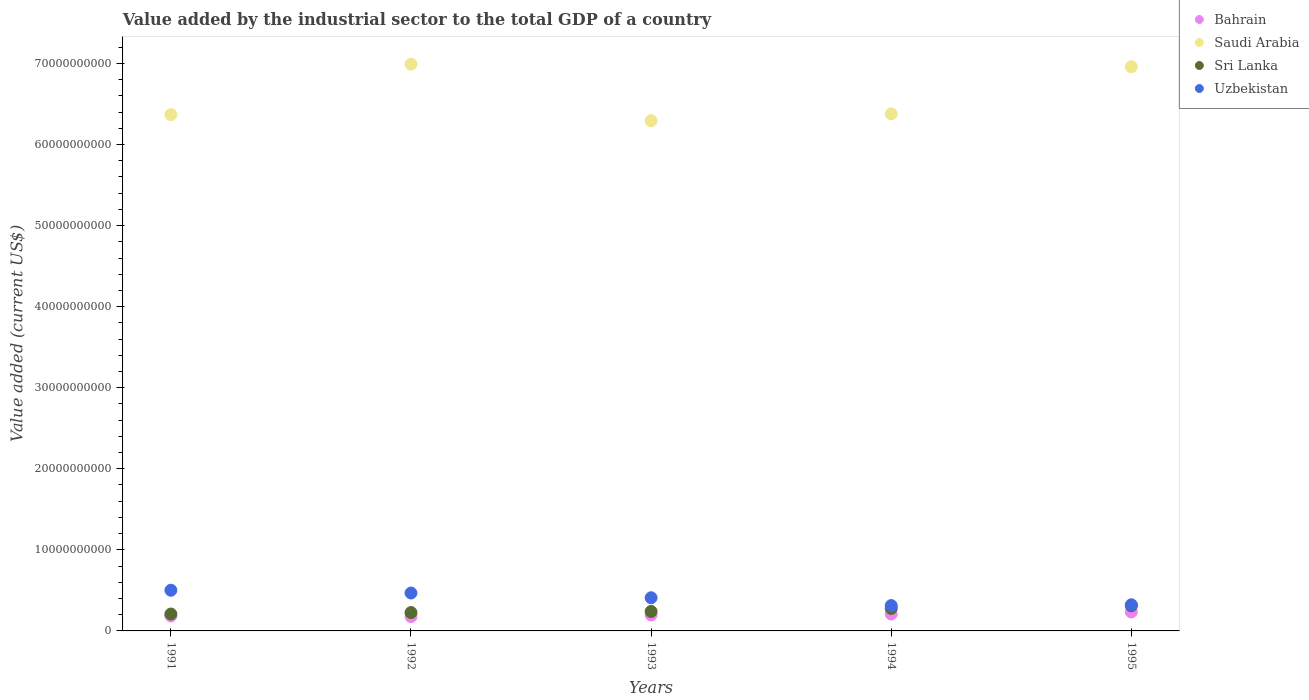What is the value added by the industrial sector to the total GDP in Saudi Arabia in 1993?
Make the answer very short. 6.29e+1. Across all years, what is the maximum value added by the industrial sector to the total GDP in Sri Lanka?
Your answer should be compact. 3.10e+09. Across all years, what is the minimum value added by the industrial sector to the total GDP in Bahrain?
Your answer should be compact. 1.77e+09. In which year was the value added by the industrial sector to the total GDP in Saudi Arabia minimum?
Offer a very short reply. 1993. What is the total value added by the industrial sector to the total GDP in Sri Lanka in the graph?
Provide a succinct answer. 1.26e+1. What is the difference between the value added by the industrial sector to the total GDP in Saudi Arabia in 1992 and that in 1994?
Make the answer very short. 6.12e+09. What is the difference between the value added by the industrial sector to the total GDP in Uzbekistan in 1993 and the value added by the industrial sector to the total GDP in Saudi Arabia in 1994?
Your response must be concise. -5.97e+1. What is the average value added by the industrial sector to the total GDP in Sri Lanka per year?
Provide a short and direct response. 2.52e+09. In the year 1991, what is the difference between the value added by the industrial sector to the total GDP in Saudi Arabia and value added by the industrial sector to the total GDP in Bahrain?
Your answer should be compact. 6.18e+1. In how many years, is the value added by the industrial sector to the total GDP in Sri Lanka greater than 24000000000 US$?
Ensure brevity in your answer.  0. What is the ratio of the value added by the industrial sector to the total GDP in Bahrain in 1991 to that in 1993?
Your answer should be very brief. 0.93. Is the value added by the industrial sector to the total GDP in Sri Lanka in 1992 less than that in 1995?
Your response must be concise. Yes. Is the difference between the value added by the industrial sector to the total GDP in Saudi Arabia in 1994 and 1995 greater than the difference between the value added by the industrial sector to the total GDP in Bahrain in 1994 and 1995?
Provide a succinct answer. No. What is the difference between the highest and the second highest value added by the industrial sector to the total GDP in Uzbekistan?
Your answer should be compact. 3.42e+08. What is the difference between the highest and the lowest value added by the industrial sector to the total GDP in Bahrain?
Make the answer very short. 5.69e+08. How many dotlines are there?
Give a very brief answer. 4. How many years are there in the graph?
Provide a short and direct response. 5. Does the graph contain any zero values?
Your response must be concise. No. How many legend labels are there?
Your answer should be very brief. 4. How are the legend labels stacked?
Keep it short and to the point. Vertical. What is the title of the graph?
Provide a succinct answer. Value added by the industrial sector to the total GDP of a country. Does "Slovenia" appear as one of the legend labels in the graph?
Give a very brief answer. No. What is the label or title of the X-axis?
Your answer should be very brief. Years. What is the label or title of the Y-axis?
Keep it short and to the point. Value added (current US$). What is the Value added (current US$) in Bahrain in 1991?
Your answer should be very brief. 1.84e+09. What is the Value added (current US$) in Saudi Arabia in 1991?
Give a very brief answer. 6.37e+1. What is the Value added (current US$) of Sri Lanka in 1991?
Offer a very short reply. 2.09e+09. What is the Value added (current US$) of Uzbekistan in 1991?
Offer a terse response. 5.02e+09. What is the Value added (current US$) of Bahrain in 1992?
Your response must be concise. 1.77e+09. What is the Value added (current US$) in Saudi Arabia in 1992?
Your response must be concise. 6.99e+1. What is the Value added (current US$) of Sri Lanka in 1992?
Your answer should be very brief. 2.26e+09. What is the Value added (current US$) of Uzbekistan in 1992?
Offer a terse response. 4.68e+09. What is the Value added (current US$) in Bahrain in 1993?
Keep it short and to the point. 1.97e+09. What is the Value added (current US$) of Saudi Arabia in 1993?
Offer a terse response. 6.29e+1. What is the Value added (current US$) of Sri Lanka in 1993?
Your response must be concise. 2.40e+09. What is the Value added (current US$) in Uzbekistan in 1993?
Offer a terse response. 4.09e+09. What is the Value added (current US$) in Bahrain in 1994?
Give a very brief answer. 2.08e+09. What is the Value added (current US$) in Saudi Arabia in 1994?
Keep it short and to the point. 6.38e+1. What is the Value added (current US$) of Sri Lanka in 1994?
Offer a terse response. 2.77e+09. What is the Value added (current US$) in Uzbekistan in 1994?
Your response must be concise. 3.13e+09. What is the Value added (current US$) of Bahrain in 1995?
Your answer should be compact. 2.34e+09. What is the Value added (current US$) of Saudi Arabia in 1995?
Your answer should be compact. 6.96e+1. What is the Value added (current US$) of Sri Lanka in 1995?
Your response must be concise. 3.10e+09. What is the Value added (current US$) of Uzbekistan in 1995?
Keep it short and to the point. 3.22e+09. Across all years, what is the maximum Value added (current US$) of Bahrain?
Your response must be concise. 2.34e+09. Across all years, what is the maximum Value added (current US$) in Saudi Arabia?
Offer a very short reply. 6.99e+1. Across all years, what is the maximum Value added (current US$) in Sri Lanka?
Provide a succinct answer. 3.10e+09. Across all years, what is the maximum Value added (current US$) of Uzbekistan?
Provide a short and direct response. 5.02e+09. Across all years, what is the minimum Value added (current US$) in Bahrain?
Provide a short and direct response. 1.77e+09. Across all years, what is the minimum Value added (current US$) of Saudi Arabia?
Keep it short and to the point. 6.29e+1. Across all years, what is the minimum Value added (current US$) of Sri Lanka?
Your answer should be compact. 2.09e+09. Across all years, what is the minimum Value added (current US$) in Uzbekistan?
Keep it short and to the point. 3.13e+09. What is the total Value added (current US$) in Bahrain in the graph?
Give a very brief answer. 1.00e+1. What is the total Value added (current US$) of Saudi Arabia in the graph?
Provide a short and direct response. 3.30e+11. What is the total Value added (current US$) of Sri Lanka in the graph?
Give a very brief answer. 1.26e+1. What is the total Value added (current US$) in Uzbekistan in the graph?
Your response must be concise. 2.01e+1. What is the difference between the Value added (current US$) in Bahrain in 1991 and that in 1992?
Ensure brevity in your answer.  7.23e+07. What is the difference between the Value added (current US$) in Saudi Arabia in 1991 and that in 1992?
Offer a very short reply. -6.22e+09. What is the difference between the Value added (current US$) in Sri Lanka in 1991 and that in 1992?
Ensure brevity in your answer.  -1.77e+08. What is the difference between the Value added (current US$) of Uzbekistan in 1991 and that in 1992?
Your answer should be compact. 3.42e+08. What is the difference between the Value added (current US$) of Bahrain in 1991 and that in 1993?
Provide a short and direct response. -1.33e+08. What is the difference between the Value added (current US$) in Saudi Arabia in 1991 and that in 1993?
Provide a succinct answer. 7.51e+08. What is the difference between the Value added (current US$) in Sri Lanka in 1991 and that in 1993?
Provide a succinct answer. -3.15e+08. What is the difference between the Value added (current US$) in Uzbekistan in 1991 and that in 1993?
Offer a terse response. 9.26e+08. What is the difference between the Value added (current US$) of Bahrain in 1991 and that in 1994?
Your answer should be very brief. -2.43e+08. What is the difference between the Value added (current US$) of Saudi Arabia in 1991 and that in 1994?
Your response must be concise. -9.80e+07. What is the difference between the Value added (current US$) in Sri Lanka in 1991 and that in 1994?
Provide a succinct answer. -6.86e+08. What is the difference between the Value added (current US$) of Uzbekistan in 1991 and that in 1994?
Your answer should be very brief. 1.89e+09. What is the difference between the Value added (current US$) of Bahrain in 1991 and that in 1995?
Make the answer very short. -4.96e+08. What is the difference between the Value added (current US$) of Saudi Arabia in 1991 and that in 1995?
Offer a terse response. -5.91e+09. What is the difference between the Value added (current US$) of Sri Lanka in 1991 and that in 1995?
Give a very brief answer. -1.01e+09. What is the difference between the Value added (current US$) of Uzbekistan in 1991 and that in 1995?
Provide a succinct answer. 1.79e+09. What is the difference between the Value added (current US$) in Bahrain in 1992 and that in 1993?
Make the answer very short. -2.05e+08. What is the difference between the Value added (current US$) in Saudi Arabia in 1992 and that in 1993?
Your answer should be compact. 6.97e+09. What is the difference between the Value added (current US$) of Sri Lanka in 1992 and that in 1993?
Ensure brevity in your answer.  -1.38e+08. What is the difference between the Value added (current US$) in Uzbekistan in 1992 and that in 1993?
Ensure brevity in your answer.  5.84e+08. What is the difference between the Value added (current US$) in Bahrain in 1992 and that in 1994?
Your answer should be compact. -3.16e+08. What is the difference between the Value added (current US$) of Saudi Arabia in 1992 and that in 1994?
Provide a succinct answer. 6.12e+09. What is the difference between the Value added (current US$) of Sri Lanka in 1992 and that in 1994?
Make the answer very short. -5.09e+08. What is the difference between the Value added (current US$) in Uzbekistan in 1992 and that in 1994?
Give a very brief answer. 1.55e+09. What is the difference between the Value added (current US$) in Bahrain in 1992 and that in 1995?
Provide a short and direct response. -5.69e+08. What is the difference between the Value added (current US$) of Saudi Arabia in 1992 and that in 1995?
Your answer should be compact. 3.15e+08. What is the difference between the Value added (current US$) in Sri Lanka in 1992 and that in 1995?
Give a very brief answer. -8.35e+08. What is the difference between the Value added (current US$) of Uzbekistan in 1992 and that in 1995?
Offer a very short reply. 1.45e+09. What is the difference between the Value added (current US$) in Bahrain in 1993 and that in 1994?
Make the answer very short. -1.10e+08. What is the difference between the Value added (current US$) of Saudi Arabia in 1993 and that in 1994?
Provide a short and direct response. -8.49e+08. What is the difference between the Value added (current US$) in Sri Lanka in 1993 and that in 1994?
Your answer should be very brief. -3.71e+08. What is the difference between the Value added (current US$) in Uzbekistan in 1993 and that in 1994?
Keep it short and to the point. 9.63e+08. What is the difference between the Value added (current US$) of Bahrain in 1993 and that in 1995?
Provide a succinct answer. -3.63e+08. What is the difference between the Value added (current US$) in Saudi Arabia in 1993 and that in 1995?
Give a very brief answer. -6.66e+09. What is the difference between the Value added (current US$) in Sri Lanka in 1993 and that in 1995?
Your response must be concise. -6.97e+08. What is the difference between the Value added (current US$) of Uzbekistan in 1993 and that in 1995?
Your answer should be very brief. 8.68e+08. What is the difference between the Value added (current US$) in Bahrain in 1994 and that in 1995?
Ensure brevity in your answer.  -2.53e+08. What is the difference between the Value added (current US$) of Saudi Arabia in 1994 and that in 1995?
Your response must be concise. -5.81e+09. What is the difference between the Value added (current US$) in Sri Lanka in 1994 and that in 1995?
Give a very brief answer. -3.26e+08. What is the difference between the Value added (current US$) in Uzbekistan in 1994 and that in 1995?
Offer a terse response. -9.48e+07. What is the difference between the Value added (current US$) of Bahrain in 1991 and the Value added (current US$) of Saudi Arabia in 1992?
Your response must be concise. -6.81e+1. What is the difference between the Value added (current US$) in Bahrain in 1991 and the Value added (current US$) in Sri Lanka in 1992?
Offer a terse response. -4.23e+08. What is the difference between the Value added (current US$) in Bahrain in 1991 and the Value added (current US$) in Uzbekistan in 1992?
Provide a succinct answer. -2.84e+09. What is the difference between the Value added (current US$) of Saudi Arabia in 1991 and the Value added (current US$) of Sri Lanka in 1992?
Provide a succinct answer. 6.14e+1. What is the difference between the Value added (current US$) in Saudi Arabia in 1991 and the Value added (current US$) in Uzbekistan in 1992?
Keep it short and to the point. 5.90e+1. What is the difference between the Value added (current US$) of Sri Lanka in 1991 and the Value added (current US$) of Uzbekistan in 1992?
Your answer should be very brief. -2.59e+09. What is the difference between the Value added (current US$) of Bahrain in 1991 and the Value added (current US$) of Saudi Arabia in 1993?
Keep it short and to the point. -6.11e+1. What is the difference between the Value added (current US$) in Bahrain in 1991 and the Value added (current US$) in Sri Lanka in 1993?
Make the answer very short. -5.61e+08. What is the difference between the Value added (current US$) in Bahrain in 1991 and the Value added (current US$) in Uzbekistan in 1993?
Your answer should be compact. -2.25e+09. What is the difference between the Value added (current US$) in Saudi Arabia in 1991 and the Value added (current US$) in Sri Lanka in 1993?
Offer a very short reply. 6.13e+1. What is the difference between the Value added (current US$) in Saudi Arabia in 1991 and the Value added (current US$) in Uzbekistan in 1993?
Your answer should be very brief. 5.96e+1. What is the difference between the Value added (current US$) in Sri Lanka in 1991 and the Value added (current US$) in Uzbekistan in 1993?
Keep it short and to the point. -2.01e+09. What is the difference between the Value added (current US$) in Bahrain in 1991 and the Value added (current US$) in Saudi Arabia in 1994?
Your response must be concise. -6.19e+1. What is the difference between the Value added (current US$) in Bahrain in 1991 and the Value added (current US$) in Sri Lanka in 1994?
Keep it short and to the point. -9.31e+08. What is the difference between the Value added (current US$) of Bahrain in 1991 and the Value added (current US$) of Uzbekistan in 1994?
Ensure brevity in your answer.  -1.29e+09. What is the difference between the Value added (current US$) of Saudi Arabia in 1991 and the Value added (current US$) of Sri Lanka in 1994?
Offer a very short reply. 6.09e+1. What is the difference between the Value added (current US$) in Saudi Arabia in 1991 and the Value added (current US$) in Uzbekistan in 1994?
Your answer should be very brief. 6.06e+1. What is the difference between the Value added (current US$) of Sri Lanka in 1991 and the Value added (current US$) of Uzbekistan in 1994?
Your response must be concise. -1.04e+09. What is the difference between the Value added (current US$) of Bahrain in 1991 and the Value added (current US$) of Saudi Arabia in 1995?
Provide a short and direct response. -6.78e+1. What is the difference between the Value added (current US$) in Bahrain in 1991 and the Value added (current US$) in Sri Lanka in 1995?
Your response must be concise. -1.26e+09. What is the difference between the Value added (current US$) in Bahrain in 1991 and the Value added (current US$) in Uzbekistan in 1995?
Your answer should be compact. -1.38e+09. What is the difference between the Value added (current US$) of Saudi Arabia in 1991 and the Value added (current US$) of Sri Lanka in 1995?
Give a very brief answer. 6.06e+1. What is the difference between the Value added (current US$) in Saudi Arabia in 1991 and the Value added (current US$) in Uzbekistan in 1995?
Your response must be concise. 6.05e+1. What is the difference between the Value added (current US$) of Sri Lanka in 1991 and the Value added (current US$) of Uzbekistan in 1995?
Provide a succinct answer. -1.14e+09. What is the difference between the Value added (current US$) of Bahrain in 1992 and the Value added (current US$) of Saudi Arabia in 1993?
Offer a very short reply. -6.12e+1. What is the difference between the Value added (current US$) of Bahrain in 1992 and the Value added (current US$) of Sri Lanka in 1993?
Your answer should be very brief. -6.33e+08. What is the difference between the Value added (current US$) of Bahrain in 1992 and the Value added (current US$) of Uzbekistan in 1993?
Provide a short and direct response. -2.32e+09. What is the difference between the Value added (current US$) of Saudi Arabia in 1992 and the Value added (current US$) of Sri Lanka in 1993?
Offer a terse response. 6.75e+1. What is the difference between the Value added (current US$) of Saudi Arabia in 1992 and the Value added (current US$) of Uzbekistan in 1993?
Give a very brief answer. 6.58e+1. What is the difference between the Value added (current US$) of Sri Lanka in 1992 and the Value added (current US$) of Uzbekistan in 1993?
Provide a short and direct response. -1.83e+09. What is the difference between the Value added (current US$) in Bahrain in 1992 and the Value added (current US$) in Saudi Arabia in 1994?
Offer a terse response. -6.20e+1. What is the difference between the Value added (current US$) in Bahrain in 1992 and the Value added (current US$) in Sri Lanka in 1994?
Your response must be concise. -1.00e+09. What is the difference between the Value added (current US$) in Bahrain in 1992 and the Value added (current US$) in Uzbekistan in 1994?
Your answer should be very brief. -1.36e+09. What is the difference between the Value added (current US$) in Saudi Arabia in 1992 and the Value added (current US$) in Sri Lanka in 1994?
Offer a terse response. 6.71e+1. What is the difference between the Value added (current US$) in Saudi Arabia in 1992 and the Value added (current US$) in Uzbekistan in 1994?
Keep it short and to the point. 6.68e+1. What is the difference between the Value added (current US$) of Sri Lanka in 1992 and the Value added (current US$) of Uzbekistan in 1994?
Give a very brief answer. -8.65e+08. What is the difference between the Value added (current US$) of Bahrain in 1992 and the Value added (current US$) of Saudi Arabia in 1995?
Ensure brevity in your answer.  -6.78e+1. What is the difference between the Value added (current US$) of Bahrain in 1992 and the Value added (current US$) of Sri Lanka in 1995?
Ensure brevity in your answer.  -1.33e+09. What is the difference between the Value added (current US$) of Bahrain in 1992 and the Value added (current US$) of Uzbekistan in 1995?
Offer a very short reply. -1.46e+09. What is the difference between the Value added (current US$) of Saudi Arabia in 1992 and the Value added (current US$) of Sri Lanka in 1995?
Offer a terse response. 6.68e+1. What is the difference between the Value added (current US$) of Saudi Arabia in 1992 and the Value added (current US$) of Uzbekistan in 1995?
Ensure brevity in your answer.  6.67e+1. What is the difference between the Value added (current US$) in Sri Lanka in 1992 and the Value added (current US$) in Uzbekistan in 1995?
Ensure brevity in your answer.  -9.60e+08. What is the difference between the Value added (current US$) of Bahrain in 1993 and the Value added (current US$) of Saudi Arabia in 1994?
Keep it short and to the point. -6.18e+1. What is the difference between the Value added (current US$) in Bahrain in 1993 and the Value added (current US$) in Sri Lanka in 1994?
Your answer should be compact. -7.98e+08. What is the difference between the Value added (current US$) of Bahrain in 1993 and the Value added (current US$) of Uzbekistan in 1994?
Offer a very short reply. -1.16e+09. What is the difference between the Value added (current US$) in Saudi Arabia in 1993 and the Value added (current US$) in Sri Lanka in 1994?
Offer a very short reply. 6.02e+1. What is the difference between the Value added (current US$) in Saudi Arabia in 1993 and the Value added (current US$) in Uzbekistan in 1994?
Offer a terse response. 5.98e+1. What is the difference between the Value added (current US$) of Sri Lanka in 1993 and the Value added (current US$) of Uzbekistan in 1994?
Your answer should be compact. -7.28e+08. What is the difference between the Value added (current US$) in Bahrain in 1993 and the Value added (current US$) in Saudi Arabia in 1995?
Ensure brevity in your answer.  -6.76e+1. What is the difference between the Value added (current US$) of Bahrain in 1993 and the Value added (current US$) of Sri Lanka in 1995?
Provide a short and direct response. -1.12e+09. What is the difference between the Value added (current US$) of Bahrain in 1993 and the Value added (current US$) of Uzbekistan in 1995?
Provide a short and direct response. -1.25e+09. What is the difference between the Value added (current US$) in Saudi Arabia in 1993 and the Value added (current US$) in Sri Lanka in 1995?
Your answer should be compact. 5.98e+1. What is the difference between the Value added (current US$) in Saudi Arabia in 1993 and the Value added (current US$) in Uzbekistan in 1995?
Make the answer very short. 5.97e+1. What is the difference between the Value added (current US$) in Sri Lanka in 1993 and the Value added (current US$) in Uzbekistan in 1995?
Provide a succinct answer. -8.22e+08. What is the difference between the Value added (current US$) in Bahrain in 1994 and the Value added (current US$) in Saudi Arabia in 1995?
Make the answer very short. -6.75e+1. What is the difference between the Value added (current US$) in Bahrain in 1994 and the Value added (current US$) in Sri Lanka in 1995?
Your response must be concise. -1.01e+09. What is the difference between the Value added (current US$) of Bahrain in 1994 and the Value added (current US$) of Uzbekistan in 1995?
Offer a terse response. -1.14e+09. What is the difference between the Value added (current US$) in Saudi Arabia in 1994 and the Value added (current US$) in Sri Lanka in 1995?
Keep it short and to the point. 6.07e+1. What is the difference between the Value added (current US$) in Saudi Arabia in 1994 and the Value added (current US$) in Uzbekistan in 1995?
Your response must be concise. 6.06e+1. What is the difference between the Value added (current US$) in Sri Lanka in 1994 and the Value added (current US$) in Uzbekistan in 1995?
Ensure brevity in your answer.  -4.52e+08. What is the average Value added (current US$) of Bahrain per year?
Your response must be concise. 2.00e+09. What is the average Value added (current US$) in Saudi Arabia per year?
Keep it short and to the point. 6.60e+1. What is the average Value added (current US$) of Sri Lanka per year?
Offer a terse response. 2.52e+09. What is the average Value added (current US$) in Uzbekistan per year?
Your answer should be compact. 4.03e+09. In the year 1991, what is the difference between the Value added (current US$) in Bahrain and Value added (current US$) in Saudi Arabia?
Make the answer very short. -6.18e+1. In the year 1991, what is the difference between the Value added (current US$) in Bahrain and Value added (current US$) in Sri Lanka?
Make the answer very short. -2.45e+08. In the year 1991, what is the difference between the Value added (current US$) of Bahrain and Value added (current US$) of Uzbekistan?
Your answer should be very brief. -3.18e+09. In the year 1991, what is the difference between the Value added (current US$) in Saudi Arabia and Value added (current US$) in Sri Lanka?
Give a very brief answer. 6.16e+1. In the year 1991, what is the difference between the Value added (current US$) of Saudi Arabia and Value added (current US$) of Uzbekistan?
Ensure brevity in your answer.  5.87e+1. In the year 1991, what is the difference between the Value added (current US$) of Sri Lanka and Value added (current US$) of Uzbekistan?
Give a very brief answer. -2.93e+09. In the year 1992, what is the difference between the Value added (current US$) of Bahrain and Value added (current US$) of Saudi Arabia?
Make the answer very short. -6.81e+1. In the year 1992, what is the difference between the Value added (current US$) in Bahrain and Value added (current US$) in Sri Lanka?
Keep it short and to the point. -4.95e+08. In the year 1992, what is the difference between the Value added (current US$) in Bahrain and Value added (current US$) in Uzbekistan?
Your response must be concise. -2.91e+09. In the year 1992, what is the difference between the Value added (current US$) in Saudi Arabia and Value added (current US$) in Sri Lanka?
Ensure brevity in your answer.  6.76e+1. In the year 1992, what is the difference between the Value added (current US$) in Saudi Arabia and Value added (current US$) in Uzbekistan?
Your answer should be very brief. 6.52e+1. In the year 1992, what is the difference between the Value added (current US$) in Sri Lanka and Value added (current US$) in Uzbekistan?
Give a very brief answer. -2.41e+09. In the year 1993, what is the difference between the Value added (current US$) of Bahrain and Value added (current US$) of Saudi Arabia?
Give a very brief answer. -6.10e+1. In the year 1993, what is the difference between the Value added (current US$) of Bahrain and Value added (current US$) of Sri Lanka?
Give a very brief answer. -4.28e+08. In the year 1993, what is the difference between the Value added (current US$) of Bahrain and Value added (current US$) of Uzbekistan?
Ensure brevity in your answer.  -2.12e+09. In the year 1993, what is the difference between the Value added (current US$) in Saudi Arabia and Value added (current US$) in Sri Lanka?
Keep it short and to the point. 6.05e+1. In the year 1993, what is the difference between the Value added (current US$) of Saudi Arabia and Value added (current US$) of Uzbekistan?
Offer a terse response. 5.88e+1. In the year 1993, what is the difference between the Value added (current US$) of Sri Lanka and Value added (current US$) of Uzbekistan?
Provide a short and direct response. -1.69e+09. In the year 1994, what is the difference between the Value added (current US$) of Bahrain and Value added (current US$) of Saudi Arabia?
Offer a very short reply. -6.17e+1. In the year 1994, what is the difference between the Value added (current US$) in Bahrain and Value added (current US$) in Sri Lanka?
Keep it short and to the point. -6.88e+08. In the year 1994, what is the difference between the Value added (current US$) in Bahrain and Value added (current US$) in Uzbekistan?
Offer a very short reply. -1.04e+09. In the year 1994, what is the difference between the Value added (current US$) in Saudi Arabia and Value added (current US$) in Sri Lanka?
Provide a short and direct response. 6.10e+1. In the year 1994, what is the difference between the Value added (current US$) of Saudi Arabia and Value added (current US$) of Uzbekistan?
Keep it short and to the point. 6.07e+1. In the year 1994, what is the difference between the Value added (current US$) in Sri Lanka and Value added (current US$) in Uzbekistan?
Offer a terse response. -3.57e+08. In the year 1995, what is the difference between the Value added (current US$) of Bahrain and Value added (current US$) of Saudi Arabia?
Provide a succinct answer. -6.73e+1. In the year 1995, what is the difference between the Value added (current US$) of Bahrain and Value added (current US$) of Sri Lanka?
Provide a succinct answer. -7.61e+08. In the year 1995, what is the difference between the Value added (current US$) in Bahrain and Value added (current US$) in Uzbekistan?
Keep it short and to the point. -8.87e+08. In the year 1995, what is the difference between the Value added (current US$) of Saudi Arabia and Value added (current US$) of Sri Lanka?
Give a very brief answer. 6.65e+1. In the year 1995, what is the difference between the Value added (current US$) of Saudi Arabia and Value added (current US$) of Uzbekistan?
Make the answer very short. 6.64e+1. In the year 1995, what is the difference between the Value added (current US$) of Sri Lanka and Value added (current US$) of Uzbekistan?
Provide a succinct answer. -1.25e+08. What is the ratio of the Value added (current US$) of Bahrain in 1991 to that in 1992?
Provide a succinct answer. 1.04. What is the ratio of the Value added (current US$) of Saudi Arabia in 1991 to that in 1992?
Keep it short and to the point. 0.91. What is the ratio of the Value added (current US$) in Sri Lanka in 1991 to that in 1992?
Give a very brief answer. 0.92. What is the ratio of the Value added (current US$) of Uzbekistan in 1991 to that in 1992?
Provide a succinct answer. 1.07. What is the ratio of the Value added (current US$) in Bahrain in 1991 to that in 1993?
Ensure brevity in your answer.  0.93. What is the ratio of the Value added (current US$) in Saudi Arabia in 1991 to that in 1993?
Your response must be concise. 1.01. What is the ratio of the Value added (current US$) of Sri Lanka in 1991 to that in 1993?
Give a very brief answer. 0.87. What is the ratio of the Value added (current US$) in Uzbekistan in 1991 to that in 1993?
Your answer should be compact. 1.23. What is the ratio of the Value added (current US$) of Bahrain in 1991 to that in 1994?
Give a very brief answer. 0.88. What is the ratio of the Value added (current US$) of Sri Lanka in 1991 to that in 1994?
Your answer should be very brief. 0.75. What is the ratio of the Value added (current US$) in Uzbekistan in 1991 to that in 1994?
Provide a short and direct response. 1.6. What is the ratio of the Value added (current US$) of Bahrain in 1991 to that in 1995?
Your answer should be compact. 0.79. What is the ratio of the Value added (current US$) in Saudi Arabia in 1991 to that in 1995?
Provide a short and direct response. 0.92. What is the ratio of the Value added (current US$) of Sri Lanka in 1991 to that in 1995?
Provide a succinct answer. 0.67. What is the ratio of the Value added (current US$) in Uzbekistan in 1991 to that in 1995?
Offer a very short reply. 1.56. What is the ratio of the Value added (current US$) in Bahrain in 1992 to that in 1993?
Your answer should be very brief. 0.9. What is the ratio of the Value added (current US$) in Saudi Arabia in 1992 to that in 1993?
Make the answer very short. 1.11. What is the ratio of the Value added (current US$) in Sri Lanka in 1992 to that in 1993?
Your response must be concise. 0.94. What is the ratio of the Value added (current US$) in Uzbekistan in 1992 to that in 1993?
Keep it short and to the point. 1.14. What is the ratio of the Value added (current US$) of Bahrain in 1992 to that in 1994?
Provide a succinct answer. 0.85. What is the ratio of the Value added (current US$) in Saudi Arabia in 1992 to that in 1994?
Provide a short and direct response. 1.1. What is the ratio of the Value added (current US$) of Sri Lanka in 1992 to that in 1994?
Make the answer very short. 0.82. What is the ratio of the Value added (current US$) of Uzbekistan in 1992 to that in 1994?
Keep it short and to the point. 1.49. What is the ratio of the Value added (current US$) in Bahrain in 1992 to that in 1995?
Ensure brevity in your answer.  0.76. What is the ratio of the Value added (current US$) in Sri Lanka in 1992 to that in 1995?
Keep it short and to the point. 0.73. What is the ratio of the Value added (current US$) in Uzbekistan in 1992 to that in 1995?
Provide a succinct answer. 1.45. What is the ratio of the Value added (current US$) of Bahrain in 1993 to that in 1994?
Provide a succinct answer. 0.95. What is the ratio of the Value added (current US$) in Saudi Arabia in 1993 to that in 1994?
Make the answer very short. 0.99. What is the ratio of the Value added (current US$) of Sri Lanka in 1993 to that in 1994?
Provide a short and direct response. 0.87. What is the ratio of the Value added (current US$) of Uzbekistan in 1993 to that in 1994?
Your answer should be very brief. 1.31. What is the ratio of the Value added (current US$) in Bahrain in 1993 to that in 1995?
Your answer should be very brief. 0.84. What is the ratio of the Value added (current US$) in Saudi Arabia in 1993 to that in 1995?
Give a very brief answer. 0.9. What is the ratio of the Value added (current US$) of Sri Lanka in 1993 to that in 1995?
Your answer should be very brief. 0.78. What is the ratio of the Value added (current US$) in Uzbekistan in 1993 to that in 1995?
Provide a short and direct response. 1.27. What is the ratio of the Value added (current US$) in Bahrain in 1994 to that in 1995?
Your answer should be compact. 0.89. What is the ratio of the Value added (current US$) in Saudi Arabia in 1994 to that in 1995?
Provide a short and direct response. 0.92. What is the ratio of the Value added (current US$) of Sri Lanka in 1994 to that in 1995?
Your response must be concise. 0.89. What is the ratio of the Value added (current US$) in Uzbekistan in 1994 to that in 1995?
Ensure brevity in your answer.  0.97. What is the difference between the highest and the second highest Value added (current US$) of Bahrain?
Make the answer very short. 2.53e+08. What is the difference between the highest and the second highest Value added (current US$) of Saudi Arabia?
Provide a short and direct response. 3.15e+08. What is the difference between the highest and the second highest Value added (current US$) in Sri Lanka?
Your answer should be compact. 3.26e+08. What is the difference between the highest and the second highest Value added (current US$) of Uzbekistan?
Give a very brief answer. 3.42e+08. What is the difference between the highest and the lowest Value added (current US$) of Bahrain?
Make the answer very short. 5.69e+08. What is the difference between the highest and the lowest Value added (current US$) of Saudi Arabia?
Make the answer very short. 6.97e+09. What is the difference between the highest and the lowest Value added (current US$) of Sri Lanka?
Ensure brevity in your answer.  1.01e+09. What is the difference between the highest and the lowest Value added (current US$) of Uzbekistan?
Your answer should be compact. 1.89e+09. 